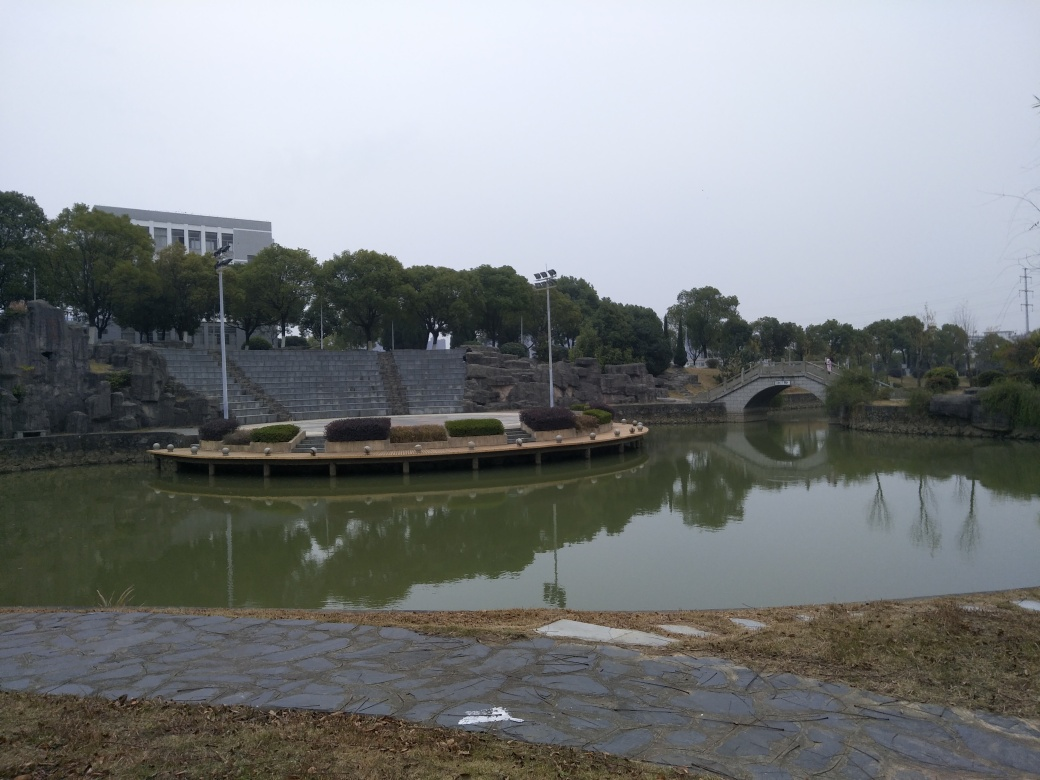What time of day does this photo seem to be taken? Given the overcast sky and the diffused lighting without strong shadows, it appears the photo was taken on a cloudy day, possibly in the late morning or midday when the light is fairly even. 